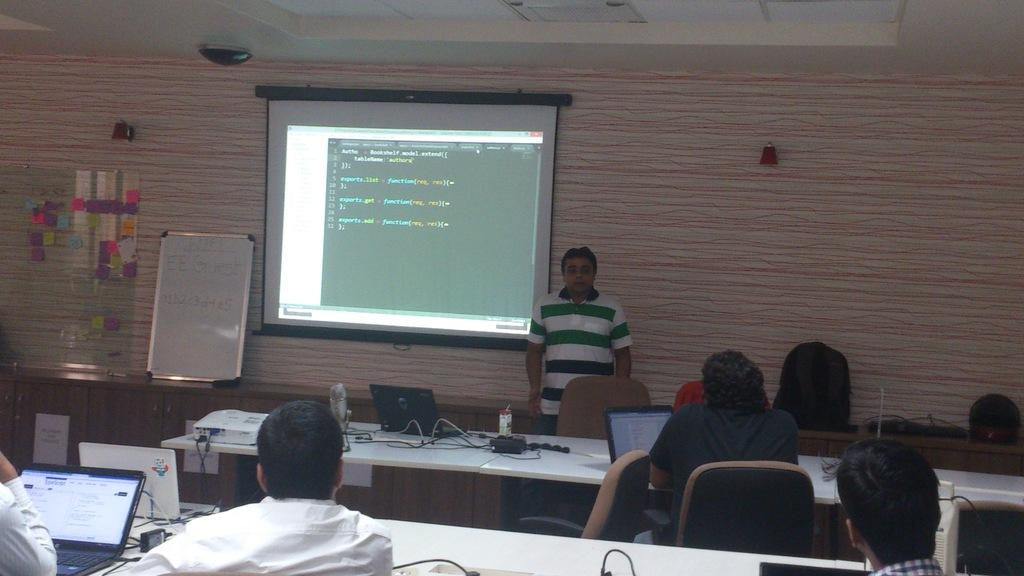What are the people in the image doing? The persons sitting on chairs are likely engaged in some activity, possibly working on laptops. Can you describe the man in the image? There is a man standing in the image. What electronic devices can be seen in the image? Laptops are present in the image. What else can be seen on the tables besides laptops? There are objects on tables, but the specific items are not mentioned in the facts. What type of furniture is present in the image? Chairs are present in the image. What can be seen in the background of the image? There is a wall, a screen, and a board visible in the background. What type of stew is being served on the board in the image? There is no stew present in the image; the board is a background element. What is the tendency of the objects on the tables in the image? The facts do not mention any tendency of the objects on the tables; they only mention that there are objects on the tables. 